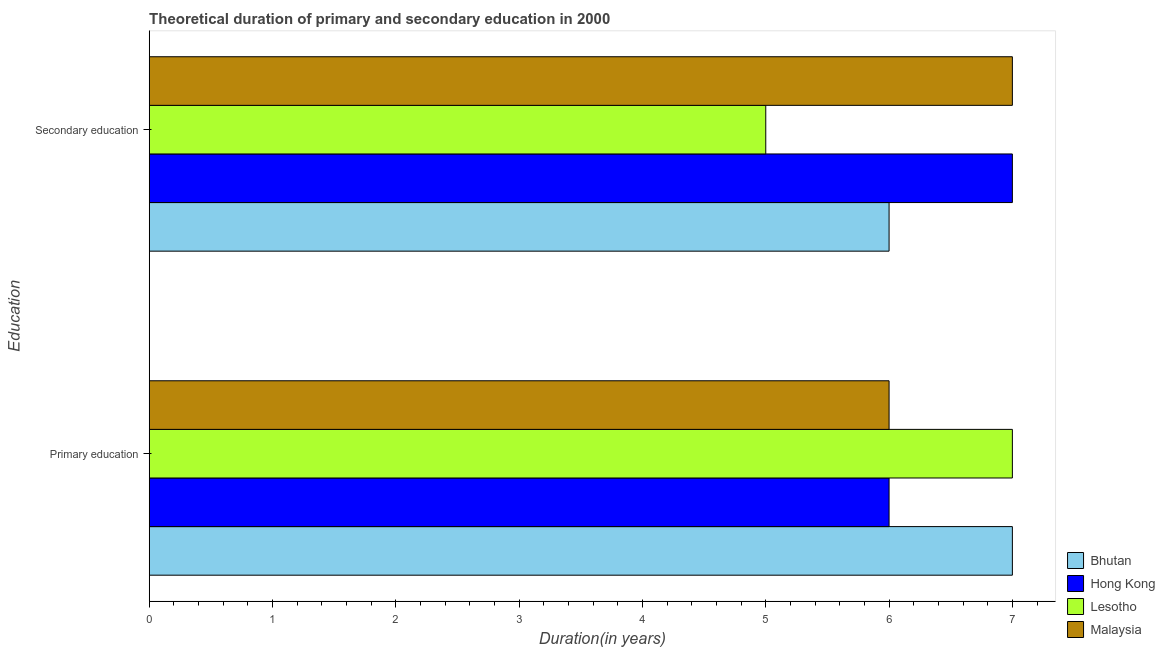How many groups of bars are there?
Ensure brevity in your answer.  2. What is the duration of primary education in Lesotho?
Your answer should be compact. 7. Across all countries, what is the maximum duration of secondary education?
Provide a short and direct response. 7. Across all countries, what is the minimum duration of primary education?
Ensure brevity in your answer.  6. In which country was the duration of primary education maximum?
Your answer should be very brief. Bhutan. In which country was the duration of secondary education minimum?
Keep it short and to the point. Lesotho. What is the total duration of primary education in the graph?
Make the answer very short. 26. What is the difference between the duration of secondary education in Malaysia and that in Bhutan?
Your response must be concise. 1. What is the average duration of primary education per country?
Offer a terse response. 6.5. What is the difference between the duration of secondary education and duration of primary education in Bhutan?
Provide a succinct answer. -1. What is the ratio of the duration of secondary education in Bhutan to that in Malaysia?
Provide a short and direct response. 0.86. What does the 3rd bar from the top in Primary education represents?
Make the answer very short. Hong Kong. What does the 4th bar from the bottom in Primary education represents?
Offer a very short reply. Malaysia. How many bars are there?
Ensure brevity in your answer.  8. Are the values on the major ticks of X-axis written in scientific E-notation?
Ensure brevity in your answer.  No. Does the graph contain grids?
Offer a very short reply. No. Where does the legend appear in the graph?
Offer a very short reply. Bottom right. How are the legend labels stacked?
Offer a terse response. Vertical. What is the title of the graph?
Give a very brief answer. Theoretical duration of primary and secondary education in 2000. Does "Solomon Islands" appear as one of the legend labels in the graph?
Ensure brevity in your answer.  No. What is the label or title of the X-axis?
Ensure brevity in your answer.  Duration(in years). What is the label or title of the Y-axis?
Offer a terse response. Education. What is the Duration(in years) in Bhutan in Primary education?
Ensure brevity in your answer.  7. What is the Duration(in years) of Hong Kong in Primary education?
Provide a short and direct response. 6. What is the Duration(in years) in Lesotho in Primary education?
Your answer should be compact. 7. What is the Duration(in years) in Hong Kong in Secondary education?
Offer a terse response. 7. What is the Duration(in years) of Lesotho in Secondary education?
Your answer should be compact. 5. Across all Education, what is the maximum Duration(in years) of Bhutan?
Your response must be concise. 7. Across all Education, what is the maximum Duration(in years) in Hong Kong?
Provide a succinct answer. 7. Across all Education, what is the maximum Duration(in years) of Malaysia?
Make the answer very short. 7. Across all Education, what is the minimum Duration(in years) of Bhutan?
Your answer should be very brief. 6. Across all Education, what is the minimum Duration(in years) of Hong Kong?
Offer a very short reply. 6. Across all Education, what is the minimum Duration(in years) in Lesotho?
Keep it short and to the point. 5. Across all Education, what is the minimum Duration(in years) in Malaysia?
Provide a succinct answer. 6. What is the difference between the Duration(in years) in Hong Kong in Primary education and that in Secondary education?
Give a very brief answer. -1. What is the difference between the Duration(in years) in Lesotho in Primary education and that in Secondary education?
Offer a terse response. 2. What is the difference between the Duration(in years) in Bhutan in Primary education and the Duration(in years) in Hong Kong in Secondary education?
Make the answer very short. 0. What is the difference between the Duration(in years) in Bhutan in Primary education and the Duration(in years) in Lesotho in Secondary education?
Offer a very short reply. 2. What is the difference between the Duration(in years) of Bhutan in Primary education and the Duration(in years) of Malaysia in Secondary education?
Your answer should be very brief. 0. What is the average Duration(in years) of Bhutan per Education?
Ensure brevity in your answer.  6.5. What is the difference between the Duration(in years) of Bhutan and Duration(in years) of Lesotho in Primary education?
Provide a short and direct response. 0. What is the difference between the Duration(in years) of Hong Kong and Duration(in years) of Lesotho in Primary education?
Provide a short and direct response. -1. What is the difference between the Duration(in years) in Hong Kong and Duration(in years) in Malaysia in Primary education?
Your response must be concise. 0. What is the difference between the Duration(in years) of Bhutan and Duration(in years) of Lesotho in Secondary education?
Offer a terse response. 1. What is the difference between the Duration(in years) of Bhutan and Duration(in years) of Malaysia in Secondary education?
Your response must be concise. -1. What is the difference between the Duration(in years) in Hong Kong and Duration(in years) in Malaysia in Secondary education?
Provide a short and direct response. 0. What is the difference between the highest and the second highest Duration(in years) in Bhutan?
Your response must be concise. 1. What is the difference between the highest and the second highest Duration(in years) of Lesotho?
Your answer should be very brief. 2. What is the difference between the highest and the second highest Duration(in years) of Malaysia?
Offer a terse response. 1. What is the difference between the highest and the lowest Duration(in years) in Bhutan?
Offer a terse response. 1. What is the difference between the highest and the lowest Duration(in years) in Hong Kong?
Your answer should be compact. 1. What is the difference between the highest and the lowest Duration(in years) in Lesotho?
Make the answer very short. 2. What is the difference between the highest and the lowest Duration(in years) in Malaysia?
Ensure brevity in your answer.  1. 